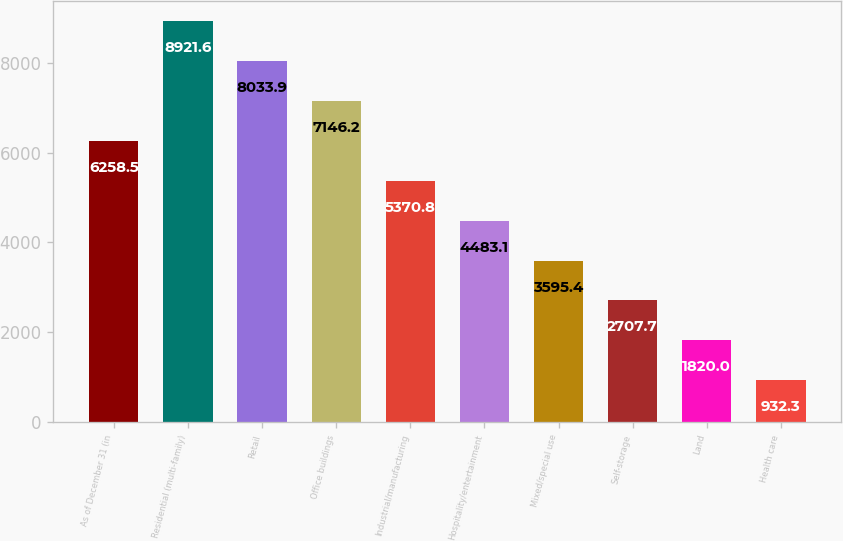Convert chart to OTSL. <chart><loc_0><loc_0><loc_500><loc_500><bar_chart><fcel>As of December 31 (in<fcel>Residential (multi-family)<fcel>Retail<fcel>Office buildings<fcel>Industrial/manufacturing<fcel>Hospitality/entertainment<fcel>Mixed/special use<fcel>Self-storage<fcel>Land<fcel>Health care<nl><fcel>6258.5<fcel>8921.6<fcel>8033.9<fcel>7146.2<fcel>5370.8<fcel>4483.1<fcel>3595.4<fcel>2707.7<fcel>1820<fcel>932.3<nl></chart> 